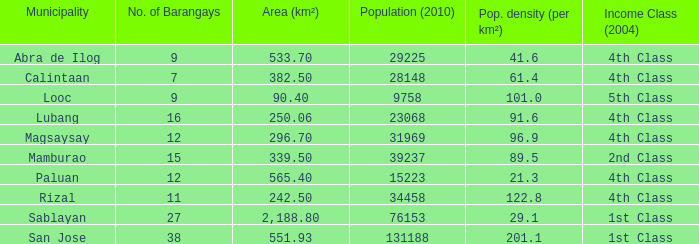How many people per square unit reside in the city of lubang? 1.0. Help me parse the entirety of this table. {'header': ['Municipality', 'No. of Barangays', 'Area (km²)', 'Population (2010)', 'Pop. density (per km²)', 'Income Class (2004)'], 'rows': [['Abra de Ilog', '9', '533.70', '29225', '41.6', '4th Class'], ['Calintaan', '7', '382.50', '28148', '61.4', '4th Class'], ['Looc', '9', '90.40', '9758', '101.0', '5th Class'], ['Lubang', '16', '250.06', '23068', '91.6', '4th Class'], ['Magsaysay', '12', '296.70', '31969', '96.9', '4th Class'], ['Mamburao', '15', '339.50', '39237', '89.5', '2nd Class'], ['Paluan', '12', '565.40', '15223', '21.3', '4th Class'], ['Rizal', '11', '242.50', '34458', '122.8', '4th Class'], ['Sablayan', '27', '2,188.80', '76153', '29.1', '1st Class'], ['San Jose', '38', '551.93', '131188', '201.1', '1st Class']]} 